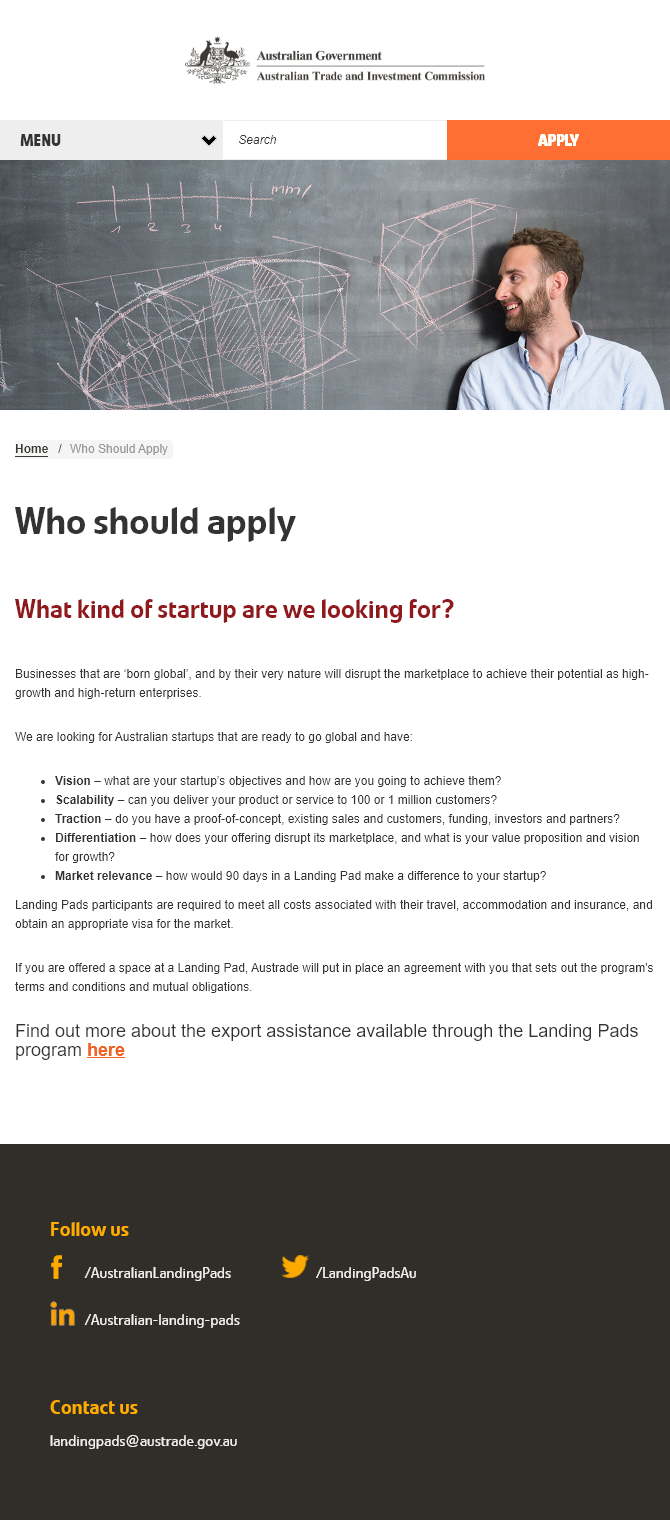List a handful of essential elements in this visual. Traction is a critical component for Australian startups looking to expand globally. Yes, it is necessary for them to have traction in order to successfully go global. Scalability is a must-have for Australian startups looking to go global, as it is crucial for their success. Yes, according to experts, having vision is a critical component that Australian startups must possess in order to succeed in expanding their businesses globally. 